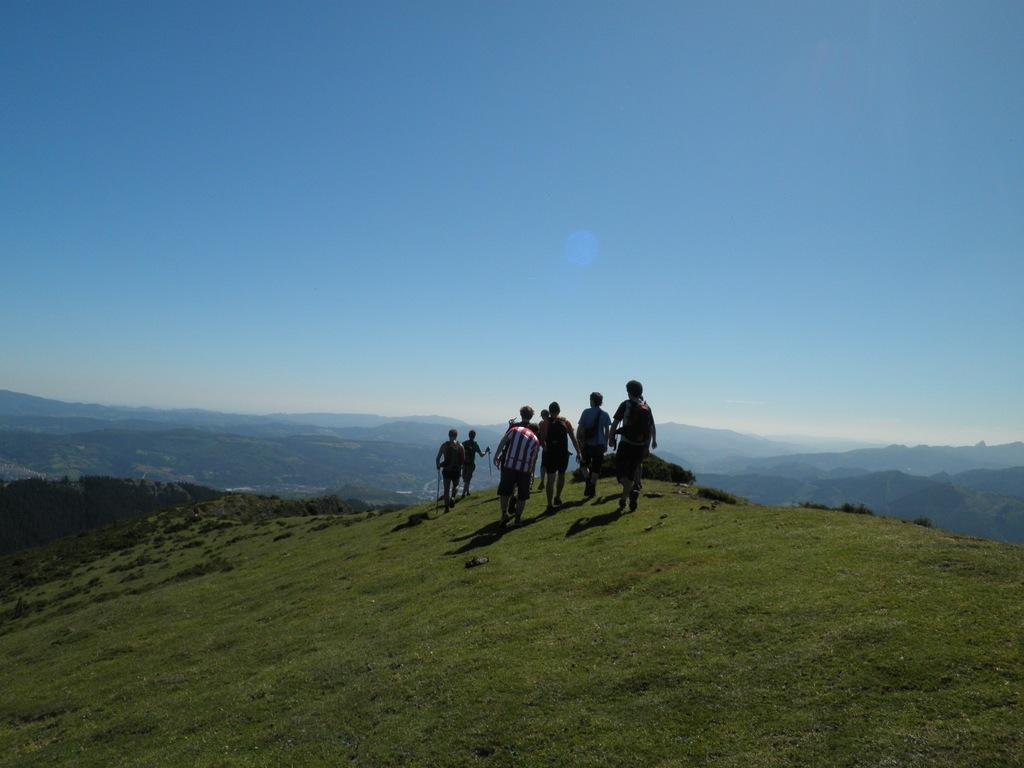Where was the image taken? The image is clicked outside. What can be seen at the top of the image? The sky is visible at the top of the image. What are the people in the image doing? There are people walking in the middle of the image. What type of cough medicine is being advertised in the image? There is no cough medicine or advertisement present in the image. What is the relationship between the people in the image and their mother? There is no information about the people's mother in the image. 